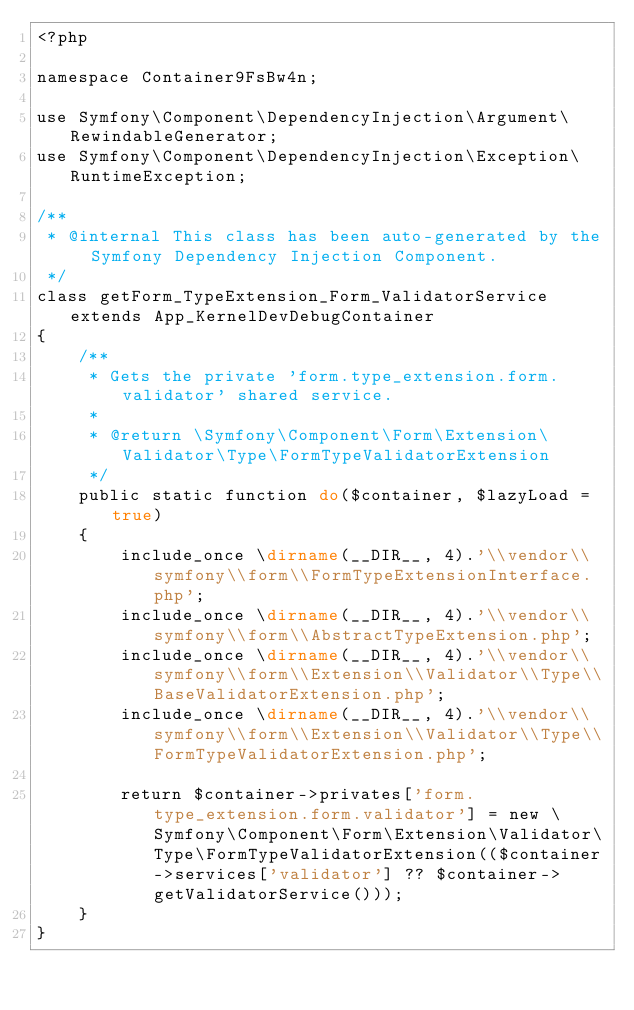Convert code to text. <code><loc_0><loc_0><loc_500><loc_500><_PHP_><?php

namespace Container9FsBw4n;

use Symfony\Component\DependencyInjection\Argument\RewindableGenerator;
use Symfony\Component\DependencyInjection\Exception\RuntimeException;

/**
 * @internal This class has been auto-generated by the Symfony Dependency Injection Component.
 */
class getForm_TypeExtension_Form_ValidatorService extends App_KernelDevDebugContainer
{
    /**
     * Gets the private 'form.type_extension.form.validator' shared service.
     *
     * @return \Symfony\Component\Form\Extension\Validator\Type\FormTypeValidatorExtension
     */
    public static function do($container, $lazyLoad = true)
    {
        include_once \dirname(__DIR__, 4).'\\vendor\\symfony\\form\\FormTypeExtensionInterface.php';
        include_once \dirname(__DIR__, 4).'\\vendor\\symfony\\form\\AbstractTypeExtension.php';
        include_once \dirname(__DIR__, 4).'\\vendor\\symfony\\form\\Extension\\Validator\\Type\\BaseValidatorExtension.php';
        include_once \dirname(__DIR__, 4).'\\vendor\\symfony\\form\\Extension\\Validator\\Type\\FormTypeValidatorExtension.php';

        return $container->privates['form.type_extension.form.validator'] = new \Symfony\Component\Form\Extension\Validator\Type\FormTypeValidatorExtension(($container->services['validator'] ?? $container->getValidatorService()));
    }
}
</code> 